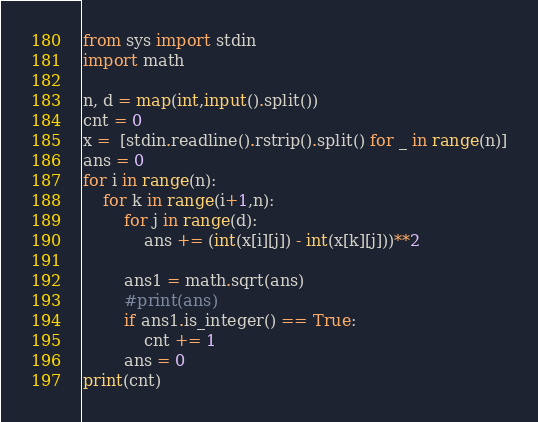<code> <loc_0><loc_0><loc_500><loc_500><_Python_>from sys import stdin
import math

n, d = map(int,input().split())
cnt = 0
x =  [stdin.readline().rstrip().split() for _ in range(n)]
ans = 0
for i in range(n):
	for k in range(i+1,n):
		for j in range(d):
			ans += (int(x[i][j]) - int(x[k][j]))**2

		ans1 = math.sqrt(ans)
		#print(ans)
		if ans1.is_integer() == True: 
			cnt += 1
		ans = 0
print(cnt)</code> 